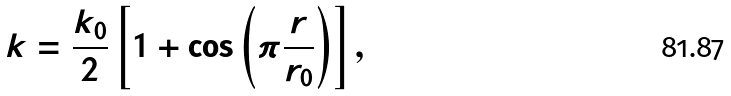Convert formula to latex. <formula><loc_0><loc_0><loc_500><loc_500>k = \frac { k _ { 0 } } { 2 } \left [ 1 + \cos \left ( \pi \frac { r } { r _ { 0 } } \right ) \right ] ,</formula> 